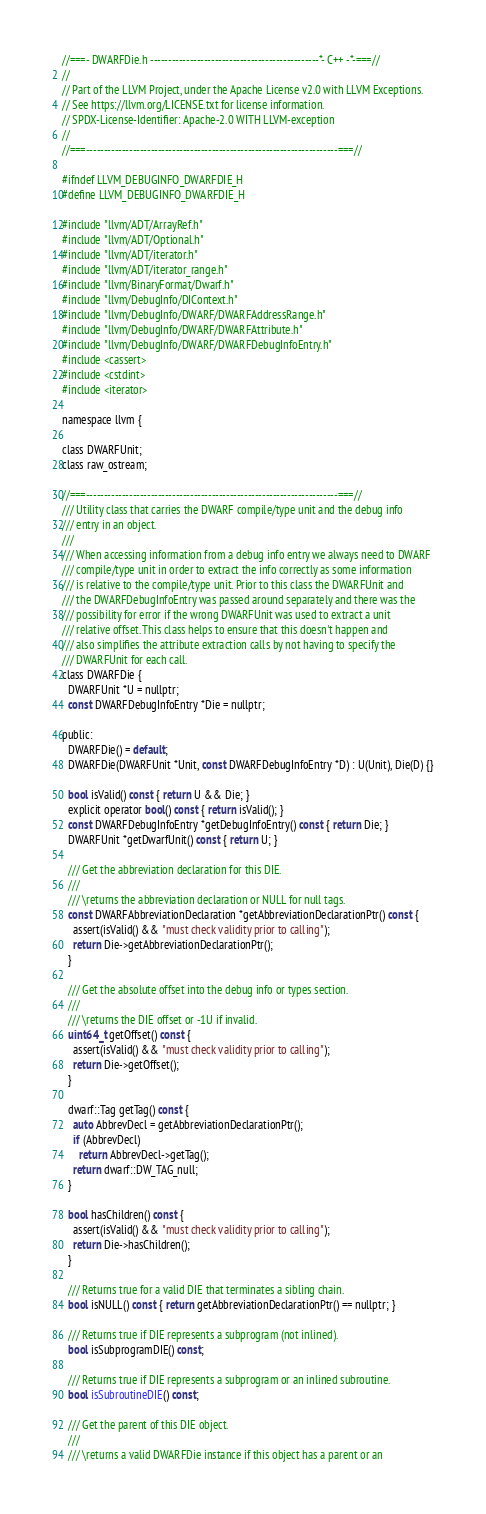<code> <loc_0><loc_0><loc_500><loc_500><_C_>//===- DWARFDie.h -----------------------------------------------*- C++ -*-===//
//
// Part of the LLVM Project, under the Apache License v2.0 with LLVM Exceptions.
// See https://llvm.org/LICENSE.txt for license information.
// SPDX-License-Identifier: Apache-2.0 WITH LLVM-exception
//
//===----------------------------------------------------------------------===//

#ifndef LLVM_DEBUGINFO_DWARFDIE_H
#define LLVM_DEBUGINFO_DWARFDIE_H

#include "llvm/ADT/ArrayRef.h"
#include "llvm/ADT/Optional.h"
#include "llvm/ADT/iterator.h"
#include "llvm/ADT/iterator_range.h"
#include "llvm/BinaryFormat/Dwarf.h"
#include "llvm/DebugInfo/DIContext.h"
#include "llvm/DebugInfo/DWARF/DWARFAddressRange.h"
#include "llvm/DebugInfo/DWARF/DWARFAttribute.h"
#include "llvm/DebugInfo/DWARF/DWARFDebugInfoEntry.h"
#include <cassert>
#include <cstdint>
#include <iterator>

namespace llvm {

class DWARFUnit;
class raw_ostream;

//===----------------------------------------------------------------------===//
/// Utility class that carries the DWARF compile/type unit and the debug info
/// entry in an object.
///
/// When accessing information from a debug info entry we always need to DWARF
/// compile/type unit in order to extract the info correctly as some information
/// is relative to the compile/type unit. Prior to this class the DWARFUnit and
/// the DWARFDebugInfoEntry was passed around separately and there was the
/// possibility for error if the wrong DWARFUnit was used to extract a unit
/// relative offset. This class helps to ensure that this doesn't happen and
/// also simplifies the attribute extraction calls by not having to specify the
/// DWARFUnit for each call.
class DWARFDie {
  DWARFUnit *U = nullptr;
  const DWARFDebugInfoEntry *Die = nullptr;

public:
  DWARFDie() = default;
  DWARFDie(DWARFUnit *Unit, const DWARFDebugInfoEntry *D) : U(Unit), Die(D) {}

  bool isValid() const { return U && Die; }
  explicit operator bool() const { return isValid(); }
  const DWARFDebugInfoEntry *getDebugInfoEntry() const { return Die; }
  DWARFUnit *getDwarfUnit() const { return U; }

  /// Get the abbreviation declaration for this DIE.
  ///
  /// \returns the abbreviation declaration or NULL for null tags.
  const DWARFAbbreviationDeclaration *getAbbreviationDeclarationPtr() const {
    assert(isValid() && "must check validity prior to calling");
    return Die->getAbbreviationDeclarationPtr();
  }

  /// Get the absolute offset into the debug info or types section.
  ///
  /// \returns the DIE offset or -1U if invalid.
  uint64_t getOffset() const {
    assert(isValid() && "must check validity prior to calling");
    return Die->getOffset();
  }

  dwarf::Tag getTag() const {
    auto AbbrevDecl = getAbbreviationDeclarationPtr();
    if (AbbrevDecl)
      return AbbrevDecl->getTag();
    return dwarf::DW_TAG_null;
  }

  bool hasChildren() const {
    assert(isValid() && "must check validity prior to calling");
    return Die->hasChildren();
  }

  /// Returns true for a valid DIE that terminates a sibling chain.
  bool isNULL() const { return getAbbreviationDeclarationPtr() == nullptr; }

  /// Returns true if DIE represents a subprogram (not inlined).
  bool isSubprogramDIE() const;

  /// Returns true if DIE represents a subprogram or an inlined subroutine.
  bool isSubroutineDIE() const;

  /// Get the parent of this DIE object.
  ///
  /// \returns a valid DWARFDie instance if this object has a parent or an</code> 